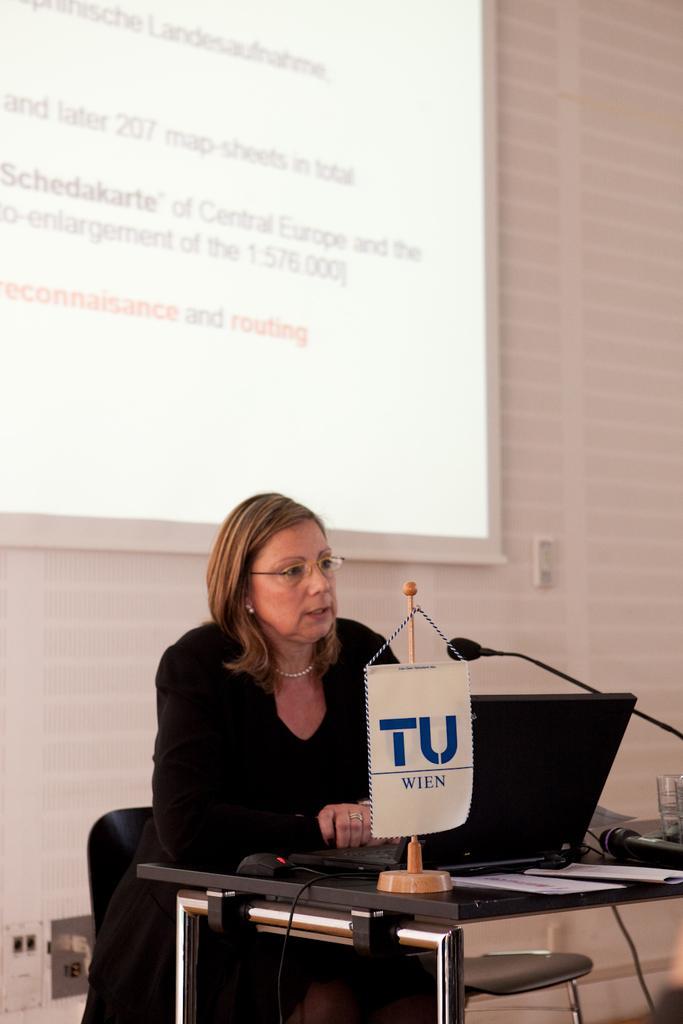Describe this image in one or two sentences. In this image I see a woman who is sitting on the chair and there is a table in front of her, on which there is a laptop, monitor and other few things. In the background I see the screen and the wall. 